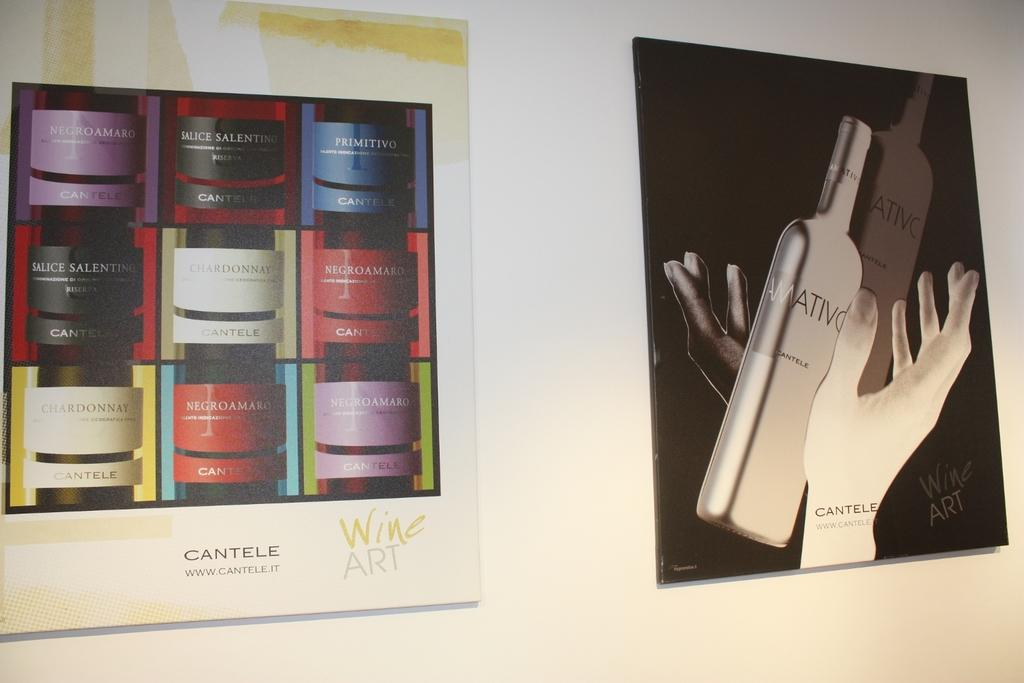<image>
Render a clear and concise summary of the photo. Two picture of wine bottles, one of which is labelled cantele. 